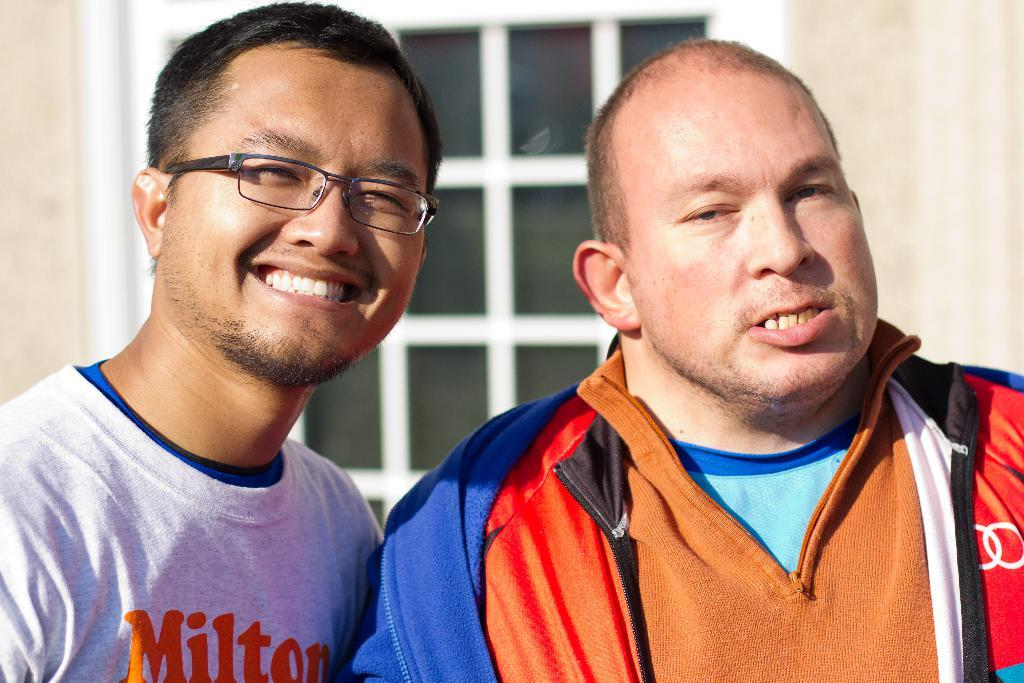How many people are in the foreground of the image? There are two men in the foreground of the image. What can be seen in the background of the image? There is a wall and a window in the background of the image. What type of wave can be seen crashing against the cemetery in the image? There is no wave or cemetery present in the image; it features two men in the foreground and a wall and window in the background. 